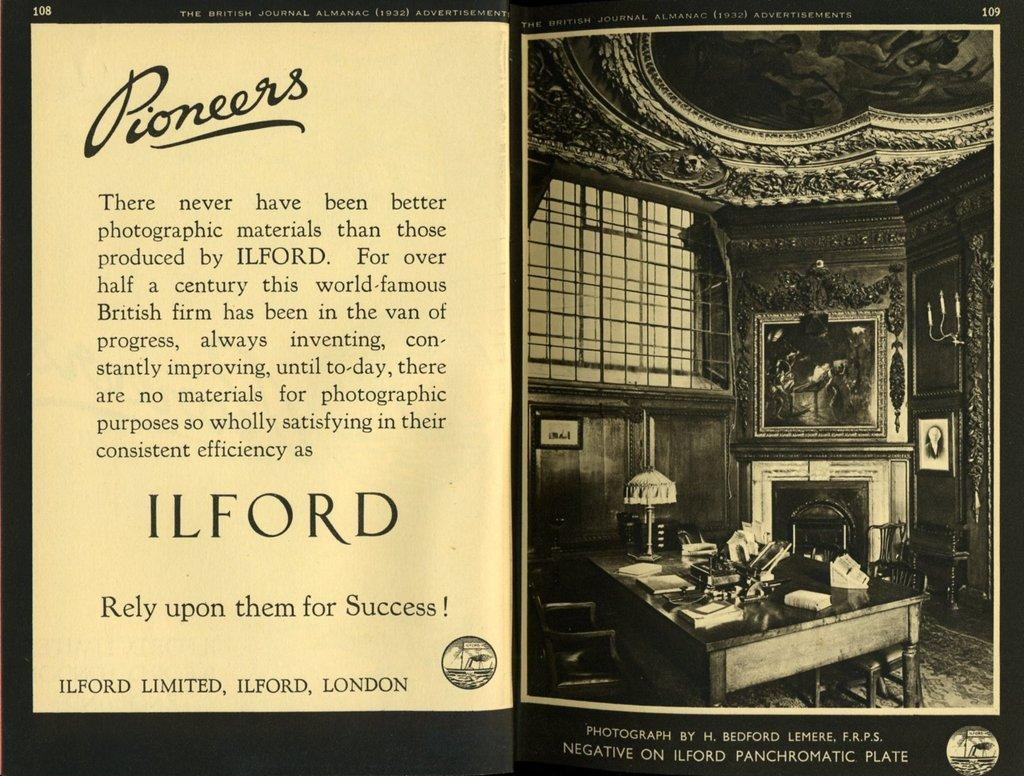What is featured on the poster in the image? The poster contains images of books and a lamp. What else can be seen on the poster? There is text written on the poster. What objects are present on the table in the image? The information provided does not specify the objects on the table. What type of furniture is visible in the image? There are chairs in the image. What is hanging on the wall in the image? There are frames on the wall in the image. Where is the pail located in the image? There is no pail present in the image. What type of arch can be seen in the image? There is no arch present in the image. 